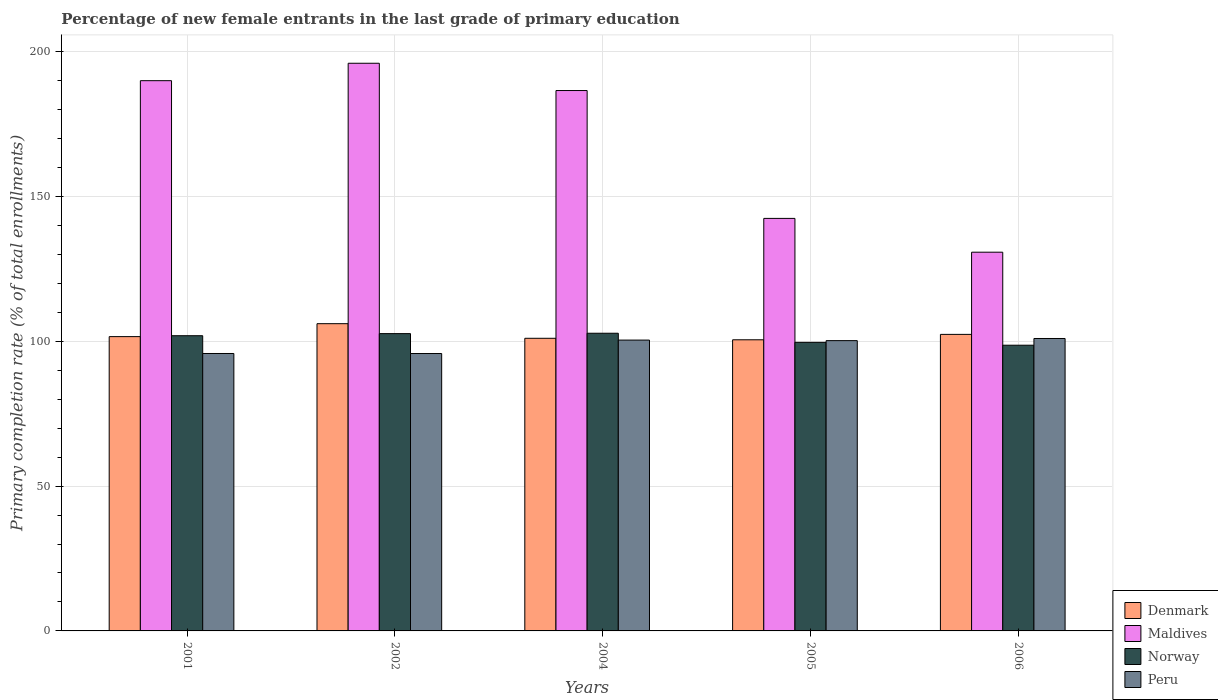How many groups of bars are there?
Offer a very short reply. 5. Are the number of bars per tick equal to the number of legend labels?
Your response must be concise. Yes. Are the number of bars on each tick of the X-axis equal?
Your answer should be very brief. Yes. How many bars are there on the 4th tick from the left?
Make the answer very short. 4. How many bars are there on the 5th tick from the right?
Give a very brief answer. 4. What is the label of the 3rd group of bars from the left?
Your answer should be compact. 2004. What is the percentage of new female entrants in Maldives in 2002?
Provide a short and direct response. 195.94. Across all years, what is the maximum percentage of new female entrants in Peru?
Your answer should be compact. 100.94. Across all years, what is the minimum percentage of new female entrants in Norway?
Provide a succinct answer. 98.62. In which year was the percentage of new female entrants in Maldives maximum?
Provide a succinct answer. 2002. In which year was the percentage of new female entrants in Maldives minimum?
Provide a short and direct response. 2006. What is the total percentage of new female entrants in Peru in the graph?
Offer a very short reply. 493.04. What is the difference between the percentage of new female entrants in Norway in 2002 and that in 2004?
Ensure brevity in your answer.  -0.13. What is the difference between the percentage of new female entrants in Maldives in 2005 and the percentage of new female entrants in Norway in 2002?
Your response must be concise. 39.77. What is the average percentage of new female entrants in Peru per year?
Provide a succinct answer. 98.61. In the year 2002, what is the difference between the percentage of new female entrants in Peru and percentage of new female entrants in Maldives?
Your response must be concise. -100.19. In how many years, is the percentage of new female entrants in Maldives greater than 100 %?
Keep it short and to the point. 5. What is the ratio of the percentage of new female entrants in Norway in 2001 to that in 2005?
Your response must be concise. 1.02. What is the difference between the highest and the second highest percentage of new female entrants in Denmark?
Provide a short and direct response. 3.7. What is the difference between the highest and the lowest percentage of new female entrants in Peru?
Your answer should be compact. 5.18. In how many years, is the percentage of new female entrants in Peru greater than the average percentage of new female entrants in Peru taken over all years?
Provide a short and direct response. 3. Is the sum of the percentage of new female entrants in Peru in 2002 and 2006 greater than the maximum percentage of new female entrants in Norway across all years?
Your response must be concise. Yes. How many years are there in the graph?
Provide a short and direct response. 5. What is the difference between two consecutive major ticks on the Y-axis?
Ensure brevity in your answer.  50. Are the values on the major ticks of Y-axis written in scientific E-notation?
Ensure brevity in your answer.  No. Does the graph contain grids?
Your response must be concise. Yes. How many legend labels are there?
Your answer should be compact. 4. How are the legend labels stacked?
Provide a succinct answer. Vertical. What is the title of the graph?
Give a very brief answer. Percentage of new female entrants in the last grade of primary education. Does "Italy" appear as one of the legend labels in the graph?
Your answer should be compact. No. What is the label or title of the X-axis?
Ensure brevity in your answer.  Years. What is the label or title of the Y-axis?
Give a very brief answer. Primary completion rate (% of total enrollments). What is the Primary completion rate (% of total enrollments) of Denmark in 2001?
Offer a terse response. 101.58. What is the Primary completion rate (% of total enrollments) of Maldives in 2001?
Offer a very short reply. 189.93. What is the Primary completion rate (% of total enrollments) of Norway in 2001?
Ensure brevity in your answer.  101.9. What is the Primary completion rate (% of total enrollments) in Peru in 2001?
Your answer should be very brief. 95.76. What is the Primary completion rate (% of total enrollments) of Denmark in 2002?
Your response must be concise. 106.05. What is the Primary completion rate (% of total enrollments) in Maldives in 2002?
Provide a short and direct response. 195.94. What is the Primary completion rate (% of total enrollments) in Norway in 2002?
Ensure brevity in your answer.  102.62. What is the Primary completion rate (% of total enrollments) of Peru in 2002?
Make the answer very short. 95.75. What is the Primary completion rate (% of total enrollments) in Denmark in 2004?
Your answer should be very brief. 101.01. What is the Primary completion rate (% of total enrollments) of Maldives in 2004?
Your answer should be very brief. 186.52. What is the Primary completion rate (% of total enrollments) of Norway in 2004?
Your answer should be compact. 102.75. What is the Primary completion rate (% of total enrollments) of Peru in 2004?
Give a very brief answer. 100.39. What is the Primary completion rate (% of total enrollments) of Denmark in 2005?
Ensure brevity in your answer.  100.49. What is the Primary completion rate (% of total enrollments) in Maldives in 2005?
Your response must be concise. 142.39. What is the Primary completion rate (% of total enrollments) in Norway in 2005?
Make the answer very short. 99.61. What is the Primary completion rate (% of total enrollments) in Peru in 2005?
Provide a short and direct response. 100.2. What is the Primary completion rate (% of total enrollments) of Denmark in 2006?
Give a very brief answer. 102.35. What is the Primary completion rate (% of total enrollments) of Maldives in 2006?
Provide a succinct answer. 130.73. What is the Primary completion rate (% of total enrollments) of Norway in 2006?
Provide a succinct answer. 98.62. What is the Primary completion rate (% of total enrollments) of Peru in 2006?
Your answer should be very brief. 100.94. Across all years, what is the maximum Primary completion rate (% of total enrollments) of Denmark?
Provide a succinct answer. 106.05. Across all years, what is the maximum Primary completion rate (% of total enrollments) in Maldives?
Make the answer very short. 195.94. Across all years, what is the maximum Primary completion rate (% of total enrollments) of Norway?
Keep it short and to the point. 102.75. Across all years, what is the maximum Primary completion rate (% of total enrollments) in Peru?
Offer a terse response. 100.94. Across all years, what is the minimum Primary completion rate (% of total enrollments) of Denmark?
Give a very brief answer. 100.49. Across all years, what is the minimum Primary completion rate (% of total enrollments) in Maldives?
Your answer should be very brief. 130.73. Across all years, what is the minimum Primary completion rate (% of total enrollments) in Norway?
Offer a very short reply. 98.62. Across all years, what is the minimum Primary completion rate (% of total enrollments) of Peru?
Ensure brevity in your answer.  95.75. What is the total Primary completion rate (% of total enrollments) of Denmark in the graph?
Your response must be concise. 511.49. What is the total Primary completion rate (% of total enrollments) in Maldives in the graph?
Make the answer very short. 845.51. What is the total Primary completion rate (% of total enrollments) in Norway in the graph?
Offer a very short reply. 505.5. What is the total Primary completion rate (% of total enrollments) in Peru in the graph?
Provide a short and direct response. 493.04. What is the difference between the Primary completion rate (% of total enrollments) in Denmark in 2001 and that in 2002?
Offer a very short reply. -4.47. What is the difference between the Primary completion rate (% of total enrollments) in Maldives in 2001 and that in 2002?
Keep it short and to the point. -6.01. What is the difference between the Primary completion rate (% of total enrollments) in Norway in 2001 and that in 2002?
Provide a succinct answer. -0.72. What is the difference between the Primary completion rate (% of total enrollments) of Peru in 2001 and that in 2002?
Give a very brief answer. 0.01. What is the difference between the Primary completion rate (% of total enrollments) in Denmark in 2001 and that in 2004?
Your answer should be very brief. 0.57. What is the difference between the Primary completion rate (% of total enrollments) of Maldives in 2001 and that in 2004?
Keep it short and to the point. 3.4. What is the difference between the Primary completion rate (% of total enrollments) in Norway in 2001 and that in 2004?
Provide a succinct answer. -0.85. What is the difference between the Primary completion rate (% of total enrollments) in Peru in 2001 and that in 2004?
Provide a succinct answer. -4.63. What is the difference between the Primary completion rate (% of total enrollments) in Denmark in 2001 and that in 2005?
Provide a succinct answer. 1.09. What is the difference between the Primary completion rate (% of total enrollments) of Maldives in 2001 and that in 2005?
Make the answer very short. 47.54. What is the difference between the Primary completion rate (% of total enrollments) in Norway in 2001 and that in 2005?
Give a very brief answer. 2.29. What is the difference between the Primary completion rate (% of total enrollments) in Peru in 2001 and that in 2005?
Offer a very short reply. -4.44. What is the difference between the Primary completion rate (% of total enrollments) in Denmark in 2001 and that in 2006?
Your answer should be compact. -0.77. What is the difference between the Primary completion rate (% of total enrollments) in Maldives in 2001 and that in 2006?
Offer a very short reply. 59.2. What is the difference between the Primary completion rate (% of total enrollments) in Norway in 2001 and that in 2006?
Make the answer very short. 3.28. What is the difference between the Primary completion rate (% of total enrollments) in Peru in 2001 and that in 2006?
Offer a very short reply. -5.17. What is the difference between the Primary completion rate (% of total enrollments) of Denmark in 2002 and that in 2004?
Provide a short and direct response. 5.04. What is the difference between the Primary completion rate (% of total enrollments) in Maldives in 2002 and that in 2004?
Make the answer very short. 9.42. What is the difference between the Primary completion rate (% of total enrollments) of Norway in 2002 and that in 2004?
Your answer should be compact. -0.13. What is the difference between the Primary completion rate (% of total enrollments) of Peru in 2002 and that in 2004?
Your answer should be compact. -4.64. What is the difference between the Primary completion rate (% of total enrollments) in Denmark in 2002 and that in 2005?
Offer a terse response. 5.56. What is the difference between the Primary completion rate (% of total enrollments) in Maldives in 2002 and that in 2005?
Offer a very short reply. 53.55. What is the difference between the Primary completion rate (% of total enrollments) of Norway in 2002 and that in 2005?
Your answer should be compact. 3.02. What is the difference between the Primary completion rate (% of total enrollments) of Peru in 2002 and that in 2005?
Offer a very short reply. -4.45. What is the difference between the Primary completion rate (% of total enrollments) in Denmark in 2002 and that in 2006?
Your answer should be very brief. 3.7. What is the difference between the Primary completion rate (% of total enrollments) in Maldives in 2002 and that in 2006?
Provide a short and direct response. 65.21. What is the difference between the Primary completion rate (% of total enrollments) in Norway in 2002 and that in 2006?
Your response must be concise. 4. What is the difference between the Primary completion rate (% of total enrollments) of Peru in 2002 and that in 2006?
Your answer should be very brief. -5.18. What is the difference between the Primary completion rate (% of total enrollments) in Denmark in 2004 and that in 2005?
Make the answer very short. 0.52. What is the difference between the Primary completion rate (% of total enrollments) of Maldives in 2004 and that in 2005?
Offer a terse response. 44.13. What is the difference between the Primary completion rate (% of total enrollments) of Norway in 2004 and that in 2005?
Give a very brief answer. 3.14. What is the difference between the Primary completion rate (% of total enrollments) in Peru in 2004 and that in 2005?
Your answer should be compact. 0.19. What is the difference between the Primary completion rate (% of total enrollments) of Denmark in 2004 and that in 2006?
Provide a short and direct response. -1.35. What is the difference between the Primary completion rate (% of total enrollments) in Maldives in 2004 and that in 2006?
Offer a very short reply. 55.8. What is the difference between the Primary completion rate (% of total enrollments) in Norway in 2004 and that in 2006?
Offer a very short reply. 4.13. What is the difference between the Primary completion rate (% of total enrollments) in Peru in 2004 and that in 2006?
Your answer should be very brief. -0.55. What is the difference between the Primary completion rate (% of total enrollments) of Denmark in 2005 and that in 2006?
Your response must be concise. -1.86. What is the difference between the Primary completion rate (% of total enrollments) of Maldives in 2005 and that in 2006?
Make the answer very short. 11.66. What is the difference between the Primary completion rate (% of total enrollments) of Norway in 2005 and that in 2006?
Provide a succinct answer. 0.99. What is the difference between the Primary completion rate (% of total enrollments) of Peru in 2005 and that in 2006?
Ensure brevity in your answer.  -0.73. What is the difference between the Primary completion rate (% of total enrollments) in Denmark in 2001 and the Primary completion rate (% of total enrollments) in Maldives in 2002?
Give a very brief answer. -94.36. What is the difference between the Primary completion rate (% of total enrollments) in Denmark in 2001 and the Primary completion rate (% of total enrollments) in Norway in 2002?
Offer a terse response. -1.04. What is the difference between the Primary completion rate (% of total enrollments) of Denmark in 2001 and the Primary completion rate (% of total enrollments) of Peru in 2002?
Offer a very short reply. 5.83. What is the difference between the Primary completion rate (% of total enrollments) in Maldives in 2001 and the Primary completion rate (% of total enrollments) in Norway in 2002?
Ensure brevity in your answer.  87.3. What is the difference between the Primary completion rate (% of total enrollments) in Maldives in 2001 and the Primary completion rate (% of total enrollments) in Peru in 2002?
Your answer should be compact. 94.18. What is the difference between the Primary completion rate (% of total enrollments) in Norway in 2001 and the Primary completion rate (% of total enrollments) in Peru in 2002?
Give a very brief answer. 6.15. What is the difference between the Primary completion rate (% of total enrollments) of Denmark in 2001 and the Primary completion rate (% of total enrollments) of Maldives in 2004?
Your response must be concise. -84.94. What is the difference between the Primary completion rate (% of total enrollments) in Denmark in 2001 and the Primary completion rate (% of total enrollments) in Norway in 2004?
Your response must be concise. -1.17. What is the difference between the Primary completion rate (% of total enrollments) in Denmark in 2001 and the Primary completion rate (% of total enrollments) in Peru in 2004?
Ensure brevity in your answer.  1.19. What is the difference between the Primary completion rate (% of total enrollments) of Maldives in 2001 and the Primary completion rate (% of total enrollments) of Norway in 2004?
Offer a terse response. 87.18. What is the difference between the Primary completion rate (% of total enrollments) of Maldives in 2001 and the Primary completion rate (% of total enrollments) of Peru in 2004?
Make the answer very short. 89.54. What is the difference between the Primary completion rate (% of total enrollments) of Norway in 2001 and the Primary completion rate (% of total enrollments) of Peru in 2004?
Keep it short and to the point. 1.51. What is the difference between the Primary completion rate (% of total enrollments) of Denmark in 2001 and the Primary completion rate (% of total enrollments) of Maldives in 2005?
Keep it short and to the point. -40.81. What is the difference between the Primary completion rate (% of total enrollments) of Denmark in 2001 and the Primary completion rate (% of total enrollments) of Norway in 2005?
Offer a very short reply. 1.98. What is the difference between the Primary completion rate (% of total enrollments) in Denmark in 2001 and the Primary completion rate (% of total enrollments) in Peru in 2005?
Your answer should be compact. 1.38. What is the difference between the Primary completion rate (% of total enrollments) in Maldives in 2001 and the Primary completion rate (% of total enrollments) in Norway in 2005?
Keep it short and to the point. 90.32. What is the difference between the Primary completion rate (% of total enrollments) in Maldives in 2001 and the Primary completion rate (% of total enrollments) in Peru in 2005?
Offer a very short reply. 89.73. What is the difference between the Primary completion rate (% of total enrollments) of Norway in 2001 and the Primary completion rate (% of total enrollments) of Peru in 2005?
Provide a succinct answer. 1.7. What is the difference between the Primary completion rate (% of total enrollments) in Denmark in 2001 and the Primary completion rate (% of total enrollments) in Maldives in 2006?
Your answer should be very brief. -29.14. What is the difference between the Primary completion rate (% of total enrollments) in Denmark in 2001 and the Primary completion rate (% of total enrollments) in Norway in 2006?
Give a very brief answer. 2.96. What is the difference between the Primary completion rate (% of total enrollments) of Denmark in 2001 and the Primary completion rate (% of total enrollments) of Peru in 2006?
Ensure brevity in your answer.  0.65. What is the difference between the Primary completion rate (% of total enrollments) in Maldives in 2001 and the Primary completion rate (% of total enrollments) in Norway in 2006?
Offer a terse response. 91.31. What is the difference between the Primary completion rate (% of total enrollments) in Maldives in 2001 and the Primary completion rate (% of total enrollments) in Peru in 2006?
Keep it short and to the point. 88.99. What is the difference between the Primary completion rate (% of total enrollments) in Norway in 2001 and the Primary completion rate (% of total enrollments) in Peru in 2006?
Offer a very short reply. 0.96. What is the difference between the Primary completion rate (% of total enrollments) in Denmark in 2002 and the Primary completion rate (% of total enrollments) in Maldives in 2004?
Give a very brief answer. -80.47. What is the difference between the Primary completion rate (% of total enrollments) in Denmark in 2002 and the Primary completion rate (% of total enrollments) in Norway in 2004?
Ensure brevity in your answer.  3.3. What is the difference between the Primary completion rate (% of total enrollments) of Denmark in 2002 and the Primary completion rate (% of total enrollments) of Peru in 2004?
Your answer should be very brief. 5.66. What is the difference between the Primary completion rate (% of total enrollments) of Maldives in 2002 and the Primary completion rate (% of total enrollments) of Norway in 2004?
Your response must be concise. 93.19. What is the difference between the Primary completion rate (% of total enrollments) in Maldives in 2002 and the Primary completion rate (% of total enrollments) in Peru in 2004?
Give a very brief answer. 95.55. What is the difference between the Primary completion rate (% of total enrollments) of Norway in 2002 and the Primary completion rate (% of total enrollments) of Peru in 2004?
Your answer should be compact. 2.23. What is the difference between the Primary completion rate (% of total enrollments) in Denmark in 2002 and the Primary completion rate (% of total enrollments) in Maldives in 2005?
Your answer should be very brief. -36.34. What is the difference between the Primary completion rate (% of total enrollments) in Denmark in 2002 and the Primary completion rate (% of total enrollments) in Norway in 2005?
Give a very brief answer. 6.44. What is the difference between the Primary completion rate (% of total enrollments) in Denmark in 2002 and the Primary completion rate (% of total enrollments) in Peru in 2005?
Your answer should be compact. 5.85. What is the difference between the Primary completion rate (% of total enrollments) in Maldives in 2002 and the Primary completion rate (% of total enrollments) in Norway in 2005?
Your response must be concise. 96.33. What is the difference between the Primary completion rate (% of total enrollments) of Maldives in 2002 and the Primary completion rate (% of total enrollments) of Peru in 2005?
Keep it short and to the point. 95.74. What is the difference between the Primary completion rate (% of total enrollments) in Norway in 2002 and the Primary completion rate (% of total enrollments) in Peru in 2005?
Offer a very short reply. 2.42. What is the difference between the Primary completion rate (% of total enrollments) of Denmark in 2002 and the Primary completion rate (% of total enrollments) of Maldives in 2006?
Your response must be concise. -24.68. What is the difference between the Primary completion rate (% of total enrollments) in Denmark in 2002 and the Primary completion rate (% of total enrollments) in Norway in 2006?
Your response must be concise. 7.43. What is the difference between the Primary completion rate (% of total enrollments) of Denmark in 2002 and the Primary completion rate (% of total enrollments) of Peru in 2006?
Your answer should be compact. 5.11. What is the difference between the Primary completion rate (% of total enrollments) of Maldives in 2002 and the Primary completion rate (% of total enrollments) of Norway in 2006?
Give a very brief answer. 97.32. What is the difference between the Primary completion rate (% of total enrollments) in Maldives in 2002 and the Primary completion rate (% of total enrollments) in Peru in 2006?
Offer a very short reply. 95. What is the difference between the Primary completion rate (% of total enrollments) in Norway in 2002 and the Primary completion rate (% of total enrollments) in Peru in 2006?
Keep it short and to the point. 1.69. What is the difference between the Primary completion rate (% of total enrollments) in Denmark in 2004 and the Primary completion rate (% of total enrollments) in Maldives in 2005?
Offer a very short reply. -41.38. What is the difference between the Primary completion rate (% of total enrollments) in Denmark in 2004 and the Primary completion rate (% of total enrollments) in Norway in 2005?
Your response must be concise. 1.4. What is the difference between the Primary completion rate (% of total enrollments) of Denmark in 2004 and the Primary completion rate (% of total enrollments) of Peru in 2005?
Provide a short and direct response. 0.81. What is the difference between the Primary completion rate (% of total enrollments) in Maldives in 2004 and the Primary completion rate (% of total enrollments) in Norway in 2005?
Your answer should be compact. 86.92. What is the difference between the Primary completion rate (% of total enrollments) in Maldives in 2004 and the Primary completion rate (% of total enrollments) in Peru in 2005?
Your answer should be very brief. 86.32. What is the difference between the Primary completion rate (% of total enrollments) of Norway in 2004 and the Primary completion rate (% of total enrollments) of Peru in 2005?
Your answer should be very brief. 2.55. What is the difference between the Primary completion rate (% of total enrollments) in Denmark in 2004 and the Primary completion rate (% of total enrollments) in Maldives in 2006?
Provide a succinct answer. -29.72. What is the difference between the Primary completion rate (% of total enrollments) in Denmark in 2004 and the Primary completion rate (% of total enrollments) in Norway in 2006?
Provide a short and direct response. 2.39. What is the difference between the Primary completion rate (% of total enrollments) of Denmark in 2004 and the Primary completion rate (% of total enrollments) of Peru in 2006?
Ensure brevity in your answer.  0.07. What is the difference between the Primary completion rate (% of total enrollments) in Maldives in 2004 and the Primary completion rate (% of total enrollments) in Norway in 2006?
Offer a very short reply. 87.9. What is the difference between the Primary completion rate (% of total enrollments) in Maldives in 2004 and the Primary completion rate (% of total enrollments) in Peru in 2006?
Your answer should be very brief. 85.59. What is the difference between the Primary completion rate (% of total enrollments) in Norway in 2004 and the Primary completion rate (% of total enrollments) in Peru in 2006?
Your answer should be compact. 1.82. What is the difference between the Primary completion rate (% of total enrollments) in Denmark in 2005 and the Primary completion rate (% of total enrollments) in Maldives in 2006?
Your answer should be compact. -30.23. What is the difference between the Primary completion rate (% of total enrollments) in Denmark in 2005 and the Primary completion rate (% of total enrollments) in Norway in 2006?
Ensure brevity in your answer.  1.87. What is the difference between the Primary completion rate (% of total enrollments) in Denmark in 2005 and the Primary completion rate (% of total enrollments) in Peru in 2006?
Give a very brief answer. -0.44. What is the difference between the Primary completion rate (% of total enrollments) in Maldives in 2005 and the Primary completion rate (% of total enrollments) in Norway in 2006?
Ensure brevity in your answer.  43.77. What is the difference between the Primary completion rate (% of total enrollments) in Maldives in 2005 and the Primary completion rate (% of total enrollments) in Peru in 2006?
Provide a short and direct response. 41.45. What is the difference between the Primary completion rate (% of total enrollments) of Norway in 2005 and the Primary completion rate (% of total enrollments) of Peru in 2006?
Give a very brief answer. -1.33. What is the average Primary completion rate (% of total enrollments) in Denmark per year?
Keep it short and to the point. 102.3. What is the average Primary completion rate (% of total enrollments) in Maldives per year?
Make the answer very short. 169.1. What is the average Primary completion rate (% of total enrollments) of Norway per year?
Ensure brevity in your answer.  101.1. What is the average Primary completion rate (% of total enrollments) in Peru per year?
Offer a terse response. 98.61. In the year 2001, what is the difference between the Primary completion rate (% of total enrollments) of Denmark and Primary completion rate (% of total enrollments) of Maldives?
Give a very brief answer. -88.34. In the year 2001, what is the difference between the Primary completion rate (% of total enrollments) in Denmark and Primary completion rate (% of total enrollments) in Norway?
Give a very brief answer. -0.32. In the year 2001, what is the difference between the Primary completion rate (% of total enrollments) of Denmark and Primary completion rate (% of total enrollments) of Peru?
Ensure brevity in your answer.  5.82. In the year 2001, what is the difference between the Primary completion rate (% of total enrollments) in Maldives and Primary completion rate (% of total enrollments) in Norway?
Keep it short and to the point. 88.03. In the year 2001, what is the difference between the Primary completion rate (% of total enrollments) of Maldives and Primary completion rate (% of total enrollments) of Peru?
Offer a terse response. 94.16. In the year 2001, what is the difference between the Primary completion rate (% of total enrollments) of Norway and Primary completion rate (% of total enrollments) of Peru?
Provide a succinct answer. 6.14. In the year 2002, what is the difference between the Primary completion rate (% of total enrollments) in Denmark and Primary completion rate (% of total enrollments) in Maldives?
Ensure brevity in your answer.  -89.89. In the year 2002, what is the difference between the Primary completion rate (% of total enrollments) of Denmark and Primary completion rate (% of total enrollments) of Norway?
Your response must be concise. 3.43. In the year 2002, what is the difference between the Primary completion rate (% of total enrollments) in Denmark and Primary completion rate (% of total enrollments) in Peru?
Your response must be concise. 10.3. In the year 2002, what is the difference between the Primary completion rate (% of total enrollments) of Maldives and Primary completion rate (% of total enrollments) of Norway?
Keep it short and to the point. 93.32. In the year 2002, what is the difference between the Primary completion rate (% of total enrollments) of Maldives and Primary completion rate (% of total enrollments) of Peru?
Offer a terse response. 100.19. In the year 2002, what is the difference between the Primary completion rate (% of total enrollments) of Norway and Primary completion rate (% of total enrollments) of Peru?
Provide a short and direct response. 6.87. In the year 2004, what is the difference between the Primary completion rate (% of total enrollments) of Denmark and Primary completion rate (% of total enrollments) of Maldives?
Provide a succinct answer. -85.52. In the year 2004, what is the difference between the Primary completion rate (% of total enrollments) of Denmark and Primary completion rate (% of total enrollments) of Norway?
Make the answer very short. -1.74. In the year 2004, what is the difference between the Primary completion rate (% of total enrollments) in Denmark and Primary completion rate (% of total enrollments) in Peru?
Your answer should be compact. 0.62. In the year 2004, what is the difference between the Primary completion rate (% of total enrollments) of Maldives and Primary completion rate (% of total enrollments) of Norway?
Offer a terse response. 83.77. In the year 2004, what is the difference between the Primary completion rate (% of total enrollments) of Maldives and Primary completion rate (% of total enrollments) of Peru?
Offer a very short reply. 86.14. In the year 2004, what is the difference between the Primary completion rate (% of total enrollments) of Norway and Primary completion rate (% of total enrollments) of Peru?
Provide a short and direct response. 2.36. In the year 2005, what is the difference between the Primary completion rate (% of total enrollments) in Denmark and Primary completion rate (% of total enrollments) in Maldives?
Your response must be concise. -41.9. In the year 2005, what is the difference between the Primary completion rate (% of total enrollments) of Denmark and Primary completion rate (% of total enrollments) of Norway?
Make the answer very short. 0.89. In the year 2005, what is the difference between the Primary completion rate (% of total enrollments) of Denmark and Primary completion rate (% of total enrollments) of Peru?
Offer a very short reply. 0.29. In the year 2005, what is the difference between the Primary completion rate (% of total enrollments) in Maldives and Primary completion rate (% of total enrollments) in Norway?
Your response must be concise. 42.78. In the year 2005, what is the difference between the Primary completion rate (% of total enrollments) in Maldives and Primary completion rate (% of total enrollments) in Peru?
Ensure brevity in your answer.  42.19. In the year 2005, what is the difference between the Primary completion rate (% of total enrollments) of Norway and Primary completion rate (% of total enrollments) of Peru?
Provide a short and direct response. -0.59. In the year 2006, what is the difference between the Primary completion rate (% of total enrollments) of Denmark and Primary completion rate (% of total enrollments) of Maldives?
Your answer should be compact. -28.37. In the year 2006, what is the difference between the Primary completion rate (% of total enrollments) in Denmark and Primary completion rate (% of total enrollments) in Norway?
Offer a terse response. 3.73. In the year 2006, what is the difference between the Primary completion rate (% of total enrollments) of Denmark and Primary completion rate (% of total enrollments) of Peru?
Give a very brief answer. 1.42. In the year 2006, what is the difference between the Primary completion rate (% of total enrollments) of Maldives and Primary completion rate (% of total enrollments) of Norway?
Keep it short and to the point. 32.1. In the year 2006, what is the difference between the Primary completion rate (% of total enrollments) in Maldives and Primary completion rate (% of total enrollments) in Peru?
Ensure brevity in your answer.  29.79. In the year 2006, what is the difference between the Primary completion rate (% of total enrollments) of Norway and Primary completion rate (% of total enrollments) of Peru?
Your response must be concise. -2.31. What is the ratio of the Primary completion rate (% of total enrollments) in Denmark in 2001 to that in 2002?
Make the answer very short. 0.96. What is the ratio of the Primary completion rate (% of total enrollments) of Maldives in 2001 to that in 2002?
Offer a terse response. 0.97. What is the ratio of the Primary completion rate (% of total enrollments) of Maldives in 2001 to that in 2004?
Provide a short and direct response. 1.02. What is the ratio of the Primary completion rate (% of total enrollments) of Peru in 2001 to that in 2004?
Give a very brief answer. 0.95. What is the ratio of the Primary completion rate (% of total enrollments) of Denmark in 2001 to that in 2005?
Your answer should be very brief. 1.01. What is the ratio of the Primary completion rate (% of total enrollments) of Maldives in 2001 to that in 2005?
Give a very brief answer. 1.33. What is the ratio of the Primary completion rate (% of total enrollments) of Peru in 2001 to that in 2005?
Give a very brief answer. 0.96. What is the ratio of the Primary completion rate (% of total enrollments) of Maldives in 2001 to that in 2006?
Provide a succinct answer. 1.45. What is the ratio of the Primary completion rate (% of total enrollments) in Norway in 2001 to that in 2006?
Ensure brevity in your answer.  1.03. What is the ratio of the Primary completion rate (% of total enrollments) of Peru in 2001 to that in 2006?
Ensure brevity in your answer.  0.95. What is the ratio of the Primary completion rate (% of total enrollments) of Denmark in 2002 to that in 2004?
Keep it short and to the point. 1.05. What is the ratio of the Primary completion rate (% of total enrollments) of Maldives in 2002 to that in 2004?
Provide a succinct answer. 1.05. What is the ratio of the Primary completion rate (% of total enrollments) in Peru in 2002 to that in 2004?
Your response must be concise. 0.95. What is the ratio of the Primary completion rate (% of total enrollments) in Denmark in 2002 to that in 2005?
Ensure brevity in your answer.  1.06. What is the ratio of the Primary completion rate (% of total enrollments) in Maldives in 2002 to that in 2005?
Ensure brevity in your answer.  1.38. What is the ratio of the Primary completion rate (% of total enrollments) in Norway in 2002 to that in 2005?
Ensure brevity in your answer.  1.03. What is the ratio of the Primary completion rate (% of total enrollments) in Peru in 2002 to that in 2005?
Make the answer very short. 0.96. What is the ratio of the Primary completion rate (% of total enrollments) of Denmark in 2002 to that in 2006?
Provide a short and direct response. 1.04. What is the ratio of the Primary completion rate (% of total enrollments) in Maldives in 2002 to that in 2006?
Your answer should be compact. 1.5. What is the ratio of the Primary completion rate (% of total enrollments) in Norway in 2002 to that in 2006?
Your answer should be compact. 1.04. What is the ratio of the Primary completion rate (% of total enrollments) of Peru in 2002 to that in 2006?
Keep it short and to the point. 0.95. What is the ratio of the Primary completion rate (% of total enrollments) in Denmark in 2004 to that in 2005?
Offer a very short reply. 1.01. What is the ratio of the Primary completion rate (% of total enrollments) in Maldives in 2004 to that in 2005?
Give a very brief answer. 1.31. What is the ratio of the Primary completion rate (% of total enrollments) in Norway in 2004 to that in 2005?
Offer a very short reply. 1.03. What is the ratio of the Primary completion rate (% of total enrollments) in Peru in 2004 to that in 2005?
Provide a short and direct response. 1. What is the ratio of the Primary completion rate (% of total enrollments) in Denmark in 2004 to that in 2006?
Provide a succinct answer. 0.99. What is the ratio of the Primary completion rate (% of total enrollments) of Maldives in 2004 to that in 2006?
Your response must be concise. 1.43. What is the ratio of the Primary completion rate (% of total enrollments) of Norway in 2004 to that in 2006?
Give a very brief answer. 1.04. What is the ratio of the Primary completion rate (% of total enrollments) of Denmark in 2005 to that in 2006?
Offer a terse response. 0.98. What is the ratio of the Primary completion rate (% of total enrollments) of Maldives in 2005 to that in 2006?
Ensure brevity in your answer.  1.09. What is the ratio of the Primary completion rate (% of total enrollments) in Norway in 2005 to that in 2006?
Provide a short and direct response. 1.01. What is the difference between the highest and the second highest Primary completion rate (% of total enrollments) in Denmark?
Provide a short and direct response. 3.7. What is the difference between the highest and the second highest Primary completion rate (% of total enrollments) in Maldives?
Provide a succinct answer. 6.01. What is the difference between the highest and the second highest Primary completion rate (% of total enrollments) of Norway?
Your response must be concise. 0.13. What is the difference between the highest and the second highest Primary completion rate (% of total enrollments) of Peru?
Keep it short and to the point. 0.55. What is the difference between the highest and the lowest Primary completion rate (% of total enrollments) of Denmark?
Your response must be concise. 5.56. What is the difference between the highest and the lowest Primary completion rate (% of total enrollments) of Maldives?
Provide a succinct answer. 65.21. What is the difference between the highest and the lowest Primary completion rate (% of total enrollments) of Norway?
Ensure brevity in your answer.  4.13. What is the difference between the highest and the lowest Primary completion rate (% of total enrollments) of Peru?
Your answer should be very brief. 5.18. 